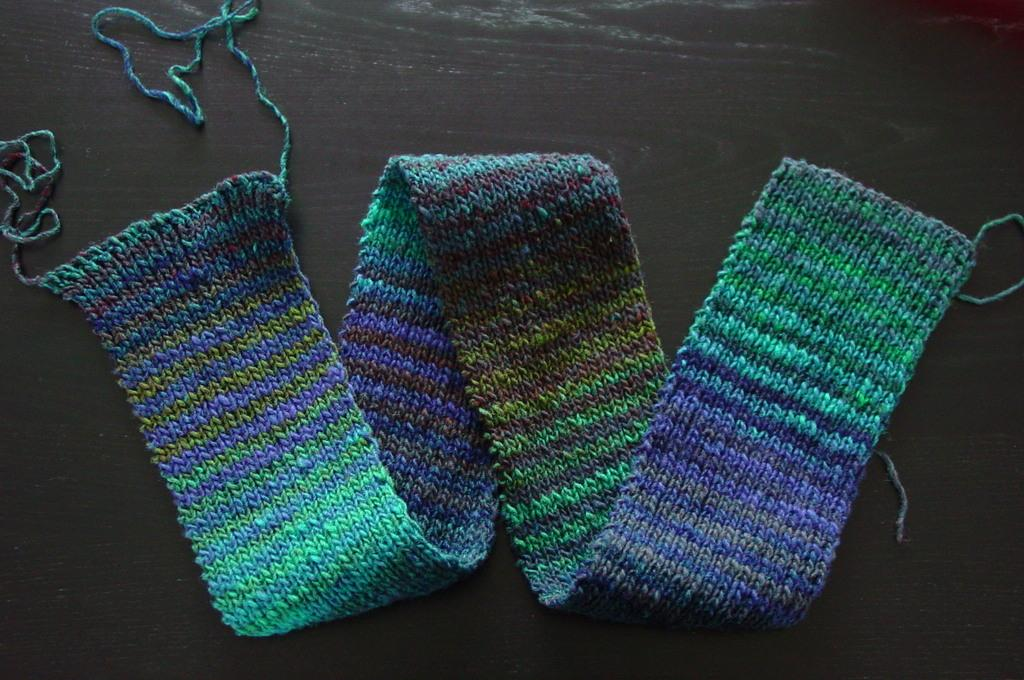What object is present on the wooden table in the image? There is a scarf in the image, and it is placed on a wooden table. What type of oil can be seen dripping from the scarf in the image? There is no oil present in the image, and the scarf is not depicted as dripping anything. 